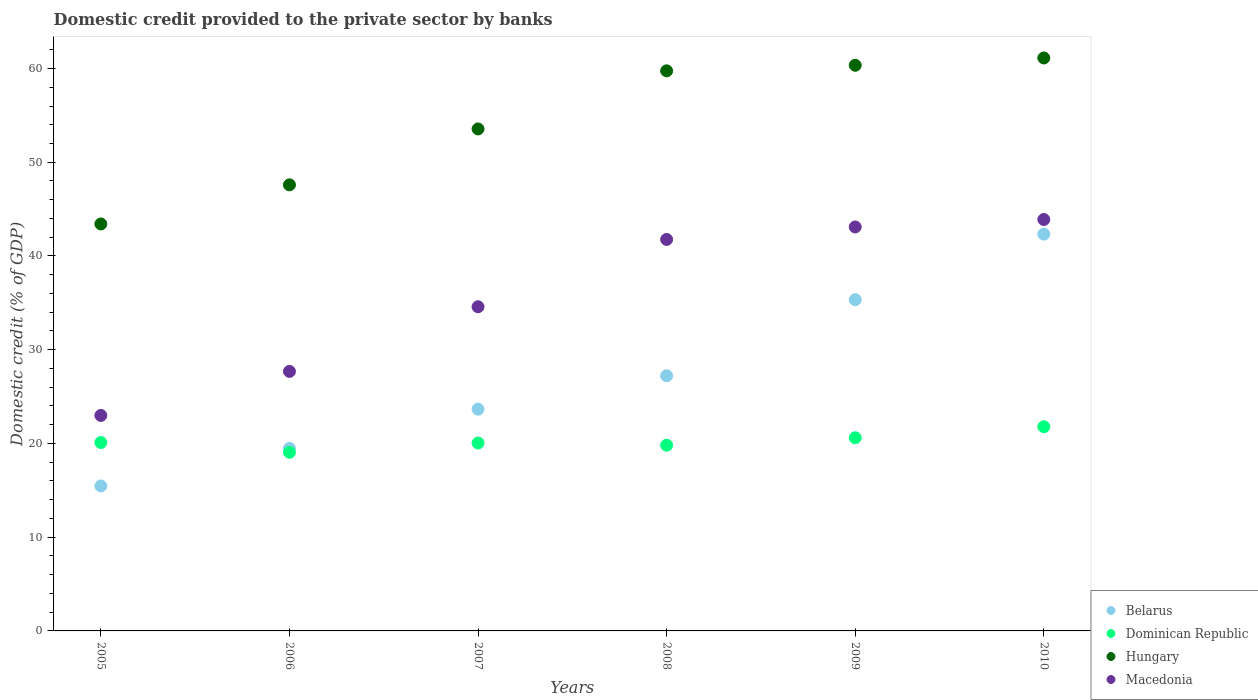How many different coloured dotlines are there?
Make the answer very short. 4. Is the number of dotlines equal to the number of legend labels?
Provide a succinct answer. Yes. What is the domestic credit provided to the private sector by banks in Belarus in 2008?
Ensure brevity in your answer.  27.22. Across all years, what is the maximum domestic credit provided to the private sector by banks in Dominican Republic?
Make the answer very short. 21.79. Across all years, what is the minimum domestic credit provided to the private sector by banks in Dominican Republic?
Provide a succinct answer. 19.05. In which year was the domestic credit provided to the private sector by banks in Hungary minimum?
Provide a short and direct response. 2005. What is the total domestic credit provided to the private sector by banks in Dominican Republic in the graph?
Your response must be concise. 121.41. What is the difference between the domestic credit provided to the private sector by banks in Dominican Republic in 2006 and that in 2010?
Ensure brevity in your answer.  -2.73. What is the difference between the domestic credit provided to the private sector by banks in Macedonia in 2005 and the domestic credit provided to the private sector by banks in Hungary in 2009?
Offer a very short reply. -37.36. What is the average domestic credit provided to the private sector by banks in Belarus per year?
Give a very brief answer. 27.25. In the year 2008, what is the difference between the domestic credit provided to the private sector by banks in Hungary and domestic credit provided to the private sector by banks in Macedonia?
Keep it short and to the point. 17.99. What is the ratio of the domestic credit provided to the private sector by banks in Hungary in 2008 to that in 2010?
Your answer should be very brief. 0.98. Is the domestic credit provided to the private sector by banks in Belarus in 2005 less than that in 2009?
Offer a very short reply. Yes. What is the difference between the highest and the second highest domestic credit provided to the private sector by banks in Dominican Republic?
Give a very brief answer. 1.18. What is the difference between the highest and the lowest domestic credit provided to the private sector by banks in Hungary?
Provide a succinct answer. 17.71. Is it the case that in every year, the sum of the domestic credit provided to the private sector by banks in Macedonia and domestic credit provided to the private sector by banks in Dominican Republic  is greater than the sum of domestic credit provided to the private sector by banks in Belarus and domestic credit provided to the private sector by banks in Hungary?
Ensure brevity in your answer.  No. Is it the case that in every year, the sum of the domestic credit provided to the private sector by banks in Macedonia and domestic credit provided to the private sector by banks in Belarus  is greater than the domestic credit provided to the private sector by banks in Hungary?
Provide a short and direct response. No. Is the domestic credit provided to the private sector by banks in Macedonia strictly less than the domestic credit provided to the private sector by banks in Belarus over the years?
Your response must be concise. No. How many years are there in the graph?
Provide a succinct answer. 6. What is the difference between two consecutive major ticks on the Y-axis?
Your response must be concise. 10. Does the graph contain any zero values?
Provide a succinct answer. No. Does the graph contain grids?
Your answer should be very brief. No. Where does the legend appear in the graph?
Provide a short and direct response. Bottom right. How many legend labels are there?
Offer a terse response. 4. What is the title of the graph?
Ensure brevity in your answer.  Domestic credit provided to the private sector by banks. What is the label or title of the X-axis?
Your answer should be compact. Years. What is the label or title of the Y-axis?
Ensure brevity in your answer.  Domestic credit (% of GDP). What is the Domestic credit (% of GDP) in Belarus in 2005?
Your response must be concise. 15.47. What is the Domestic credit (% of GDP) of Dominican Republic in 2005?
Provide a short and direct response. 20.1. What is the Domestic credit (% of GDP) in Hungary in 2005?
Offer a terse response. 43.42. What is the Domestic credit (% of GDP) of Macedonia in 2005?
Your answer should be very brief. 22.99. What is the Domestic credit (% of GDP) in Belarus in 2006?
Your answer should be compact. 19.48. What is the Domestic credit (% of GDP) in Dominican Republic in 2006?
Ensure brevity in your answer.  19.05. What is the Domestic credit (% of GDP) of Hungary in 2006?
Offer a very short reply. 47.59. What is the Domestic credit (% of GDP) in Macedonia in 2006?
Your response must be concise. 27.69. What is the Domestic credit (% of GDP) of Belarus in 2007?
Provide a short and direct response. 23.66. What is the Domestic credit (% of GDP) in Dominican Republic in 2007?
Keep it short and to the point. 20.05. What is the Domestic credit (% of GDP) in Hungary in 2007?
Make the answer very short. 53.55. What is the Domestic credit (% of GDP) in Macedonia in 2007?
Your answer should be very brief. 34.58. What is the Domestic credit (% of GDP) in Belarus in 2008?
Keep it short and to the point. 27.22. What is the Domestic credit (% of GDP) of Dominican Republic in 2008?
Ensure brevity in your answer.  19.81. What is the Domestic credit (% of GDP) of Hungary in 2008?
Make the answer very short. 59.75. What is the Domestic credit (% of GDP) in Macedonia in 2008?
Your response must be concise. 41.76. What is the Domestic credit (% of GDP) of Belarus in 2009?
Give a very brief answer. 35.34. What is the Domestic credit (% of GDP) in Dominican Republic in 2009?
Ensure brevity in your answer.  20.61. What is the Domestic credit (% of GDP) of Hungary in 2009?
Provide a succinct answer. 60.34. What is the Domestic credit (% of GDP) in Macedonia in 2009?
Offer a very short reply. 43.1. What is the Domestic credit (% of GDP) of Belarus in 2010?
Keep it short and to the point. 42.33. What is the Domestic credit (% of GDP) of Dominican Republic in 2010?
Make the answer very short. 21.79. What is the Domestic credit (% of GDP) of Hungary in 2010?
Make the answer very short. 61.12. What is the Domestic credit (% of GDP) in Macedonia in 2010?
Your answer should be very brief. 43.89. Across all years, what is the maximum Domestic credit (% of GDP) of Belarus?
Provide a short and direct response. 42.33. Across all years, what is the maximum Domestic credit (% of GDP) of Dominican Republic?
Your answer should be compact. 21.79. Across all years, what is the maximum Domestic credit (% of GDP) in Hungary?
Offer a terse response. 61.12. Across all years, what is the maximum Domestic credit (% of GDP) in Macedonia?
Offer a terse response. 43.89. Across all years, what is the minimum Domestic credit (% of GDP) in Belarus?
Provide a short and direct response. 15.47. Across all years, what is the minimum Domestic credit (% of GDP) in Dominican Republic?
Offer a terse response. 19.05. Across all years, what is the minimum Domestic credit (% of GDP) in Hungary?
Your answer should be compact. 43.42. Across all years, what is the minimum Domestic credit (% of GDP) of Macedonia?
Keep it short and to the point. 22.99. What is the total Domestic credit (% of GDP) in Belarus in the graph?
Offer a very short reply. 163.5. What is the total Domestic credit (% of GDP) of Dominican Republic in the graph?
Your response must be concise. 121.41. What is the total Domestic credit (% of GDP) in Hungary in the graph?
Make the answer very short. 325.78. What is the total Domestic credit (% of GDP) of Macedonia in the graph?
Offer a very short reply. 214.01. What is the difference between the Domestic credit (% of GDP) of Belarus in 2005 and that in 2006?
Make the answer very short. -4.01. What is the difference between the Domestic credit (% of GDP) in Dominican Republic in 2005 and that in 2006?
Provide a succinct answer. 1.05. What is the difference between the Domestic credit (% of GDP) of Hungary in 2005 and that in 2006?
Keep it short and to the point. -4.17. What is the difference between the Domestic credit (% of GDP) of Macedonia in 2005 and that in 2006?
Offer a terse response. -4.7. What is the difference between the Domestic credit (% of GDP) in Belarus in 2005 and that in 2007?
Your answer should be compact. -8.19. What is the difference between the Domestic credit (% of GDP) of Dominican Republic in 2005 and that in 2007?
Your response must be concise. 0.05. What is the difference between the Domestic credit (% of GDP) in Hungary in 2005 and that in 2007?
Make the answer very short. -10.14. What is the difference between the Domestic credit (% of GDP) of Macedonia in 2005 and that in 2007?
Your answer should be compact. -11.6. What is the difference between the Domestic credit (% of GDP) of Belarus in 2005 and that in 2008?
Provide a succinct answer. -11.76. What is the difference between the Domestic credit (% of GDP) of Dominican Republic in 2005 and that in 2008?
Offer a terse response. 0.29. What is the difference between the Domestic credit (% of GDP) in Hungary in 2005 and that in 2008?
Offer a terse response. -16.33. What is the difference between the Domestic credit (% of GDP) in Macedonia in 2005 and that in 2008?
Your response must be concise. -18.78. What is the difference between the Domestic credit (% of GDP) of Belarus in 2005 and that in 2009?
Offer a very short reply. -19.87. What is the difference between the Domestic credit (% of GDP) of Dominican Republic in 2005 and that in 2009?
Ensure brevity in your answer.  -0.5. What is the difference between the Domestic credit (% of GDP) in Hungary in 2005 and that in 2009?
Make the answer very short. -16.93. What is the difference between the Domestic credit (% of GDP) of Macedonia in 2005 and that in 2009?
Give a very brief answer. -20.11. What is the difference between the Domestic credit (% of GDP) in Belarus in 2005 and that in 2010?
Offer a terse response. -26.87. What is the difference between the Domestic credit (% of GDP) of Dominican Republic in 2005 and that in 2010?
Your answer should be compact. -1.68. What is the difference between the Domestic credit (% of GDP) of Hungary in 2005 and that in 2010?
Ensure brevity in your answer.  -17.71. What is the difference between the Domestic credit (% of GDP) in Macedonia in 2005 and that in 2010?
Make the answer very short. -20.9. What is the difference between the Domestic credit (% of GDP) of Belarus in 2006 and that in 2007?
Offer a very short reply. -4.18. What is the difference between the Domestic credit (% of GDP) of Dominican Republic in 2006 and that in 2007?
Provide a succinct answer. -1. What is the difference between the Domestic credit (% of GDP) in Hungary in 2006 and that in 2007?
Make the answer very short. -5.96. What is the difference between the Domestic credit (% of GDP) in Macedonia in 2006 and that in 2007?
Offer a terse response. -6.89. What is the difference between the Domestic credit (% of GDP) in Belarus in 2006 and that in 2008?
Offer a terse response. -7.75. What is the difference between the Domestic credit (% of GDP) in Dominican Republic in 2006 and that in 2008?
Your response must be concise. -0.76. What is the difference between the Domestic credit (% of GDP) in Hungary in 2006 and that in 2008?
Offer a terse response. -12.16. What is the difference between the Domestic credit (% of GDP) of Macedonia in 2006 and that in 2008?
Ensure brevity in your answer.  -14.08. What is the difference between the Domestic credit (% of GDP) of Belarus in 2006 and that in 2009?
Offer a terse response. -15.86. What is the difference between the Domestic credit (% of GDP) of Dominican Republic in 2006 and that in 2009?
Make the answer very short. -1.55. What is the difference between the Domestic credit (% of GDP) in Hungary in 2006 and that in 2009?
Keep it short and to the point. -12.75. What is the difference between the Domestic credit (% of GDP) of Macedonia in 2006 and that in 2009?
Provide a succinct answer. -15.41. What is the difference between the Domestic credit (% of GDP) of Belarus in 2006 and that in 2010?
Your answer should be very brief. -22.86. What is the difference between the Domestic credit (% of GDP) in Dominican Republic in 2006 and that in 2010?
Keep it short and to the point. -2.73. What is the difference between the Domestic credit (% of GDP) in Hungary in 2006 and that in 2010?
Provide a short and direct response. -13.53. What is the difference between the Domestic credit (% of GDP) in Macedonia in 2006 and that in 2010?
Your response must be concise. -16.2. What is the difference between the Domestic credit (% of GDP) of Belarus in 2007 and that in 2008?
Your answer should be very brief. -3.56. What is the difference between the Domestic credit (% of GDP) in Dominican Republic in 2007 and that in 2008?
Your answer should be compact. 0.23. What is the difference between the Domestic credit (% of GDP) of Hungary in 2007 and that in 2008?
Offer a terse response. -6.2. What is the difference between the Domestic credit (% of GDP) of Macedonia in 2007 and that in 2008?
Make the answer very short. -7.18. What is the difference between the Domestic credit (% of GDP) of Belarus in 2007 and that in 2009?
Keep it short and to the point. -11.68. What is the difference between the Domestic credit (% of GDP) in Dominican Republic in 2007 and that in 2009?
Make the answer very short. -0.56. What is the difference between the Domestic credit (% of GDP) in Hungary in 2007 and that in 2009?
Give a very brief answer. -6.79. What is the difference between the Domestic credit (% of GDP) of Macedonia in 2007 and that in 2009?
Keep it short and to the point. -8.51. What is the difference between the Domestic credit (% of GDP) in Belarus in 2007 and that in 2010?
Provide a short and direct response. -18.67. What is the difference between the Domestic credit (% of GDP) in Dominican Republic in 2007 and that in 2010?
Keep it short and to the point. -1.74. What is the difference between the Domestic credit (% of GDP) of Hungary in 2007 and that in 2010?
Give a very brief answer. -7.57. What is the difference between the Domestic credit (% of GDP) of Macedonia in 2007 and that in 2010?
Ensure brevity in your answer.  -9.31. What is the difference between the Domestic credit (% of GDP) of Belarus in 2008 and that in 2009?
Your response must be concise. -8.12. What is the difference between the Domestic credit (% of GDP) in Dominican Republic in 2008 and that in 2009?
Give a very brief answer. -0.79. What is the difference between the Domestic credit (% of GDP) of Hungary in 2008 and that in 2009?
Offer a very short reply. -0.59. What is the difference between the Domestic credit (% of GDP) of Macedonia in 2008 and that in 2009?
Your response must be concise. -1.33. What is the difference between the Domestic credit (% of GDP) in Belarus in 2008 and that in 2010?
Provide a short and direct response. -15.11. What is the difference between the Domestic credit (% of GDP) of Dominican Republic in 2008 and that in 2010?
Offer a terse response. -1.97. What is the difference between the Domestic credit (% of GDP) in Hungary in 2008 and that in 2010?
Offer a very short reply. -1.37. What is the difference between the Domestic credit (% of GDP) in Macedonia in 2008 and that in 2010?
Give a very brief answer. -2.13. What is the difference between the Domestic credit (% of GDP) of Belarus in 2009 and that in 2010?
Offer a very short reply. -6.99. What is the difference between the Domestic credit (% of GDP) of Dominican Republic in 2009 and that in 2010?
Offer a terse response. -1.18. What is the difference between the Domestic credit (% of GDP) of Hungary in 2009 and that in 2010?
Ensure brevity in your answer.  -0.78. What is the difference between the Domestic credit (% of GDP) of Macedonia in 2009 and that in 2010?
Your response must be concise. -0.8. What is the difference between the Domestic credit (% of GDP) in Belarus in 2005 and the Domestic credit (% of GDP) in Dominican Republic in 2006?
Give a very brief answer. -3.59. What is the difference between the Domestic credit (% of GDP) of Belarus in 2005 and the Domestic credit (% of GDP) of Hungary in 2006?
Make the answer very short. -32.12. What is the difference between the Domestic credit (% of GDP) of Belarus in 2005 and the Domestic credit (% of GDP) of Macedonia in 2006?
Offer a very short reply. -12.22. What is the difference between the Domestic credit (% of GDP) in Dominican Republic in 2005 and the Domestic credit (% of GDP) in Hungary in 2006?
Offer a terse response. -27.49. What is the difference between the Domestic credit (% of GDP) of Dominican Republic in 2005 and the Domestic credit (% of GDP) of Macedonia in 2006?
Your answer should be compact. -7.59. What is the difference between the Domestic credit (% of GDP) in Hungary in 2005 and the Domestic credit (% of GDP) in Macedonia in 2006?
Your response must be concise. 15.73. What is the difference between the Domestic credit (% of GDP) of Belarus in 2005 and the Domestic credit (% of GDP) of Dominican Republic in 2007?
Offer a terse response. -4.58. What is the difference between the Domestic credit (% of GDP) in Belarus in 2005 and the Domestic credit (% of GDP) in Hungary in 2007?
Your response must be concise. -38.09. What is the difference between the Domestic credit (% of GDP) of Belarus in 2005 and the Domestic credit (% of GDP) of Macedonia in 2007?
Your response must be concise. -19.12. What is the difference between the Domestic credit (% of GDP) in Dominican Republic in 2005 and the Domestic credit (% of GDP) in Hungary in 2007?
Your answer should be very brief. -33.45. What is the difference between the Domestic credit (% of GDP) of Dominican Republic in 2005 and the Domestic credit (% of GDP) of Macedonia in 2007?
Provide a short and direct response. -14.48. What is the difference between the Domestic credit (% of GDP) in Hungary in 2005 and the Domestic credit (% of GDP) in Macedonia in 2007?
Your answer should be compact. 8.83. What is the difference between the Domestic credit (% of GDP) of Belarus in 2005 and the Domestic credit (% of GDP) of Dominican Republic in 2008?
Your response must be concise. -4.35. What is the difference between the Domestic credit (% of GDP) in Belarus in 2005 and the Domestic credit (% of GDP) in Hungary in 2008?
Offer a terse response. -44.28. What is the difference between the Domestic credit (% of GDP) in Belarus in 2005 and the Domestic credit (% of GDP) in Macedonia in 2008?
Offer a very short reply. -26.3. What is the difference between the Domestic credit (% of GDP) of Dominican Republic in 2005 and the Domestic credit (% of GDP) of Hungary in 2008?
Offer a terse response. -39.65. What is the difference between the Domestic credit (% of GDP) in Dominican Republic in 2005 and the Domestic credit (% of GDP) in Macedonia in 2008?
Your answer should be compact. -21.66. What is the difference between the Domestic credit (% of GDP) of Hungary in 2005 and the Domestic credit (% of GDP) of Macedonia in 2008?
Make the answer very short. 1.65. What is the difference between the Domestic credit (% of GDP) of Belarus in 2005 and the Domestic credit (% of GDP) of Dominican Republic in 2009?
Your answer should be compact. -5.14. What is the difference between the Domestic credit (% of GDP) of Belarus in 2005 and the Domestic credit (% of GDP) of Hungary in 2009?
Your response must be concise. -44.88. What is the difference between the Domestic credit (% of GDP) of Belarus in 2005 and the Domestic credit (% of GDP) of Macedonia in 2009?
Offer a terse response. -27.63. What is the difference between the Domestic credit (% of GDP) in Dominican Republic in 2005 and the Domestic credit (% of GDP) in Hungary in 2009?
Ensure brevity in your answer.  -40.24. What is the difference between the Domestic credit (% of GDP) of Dominican Republic in 2005 and the Domestic credit (% of GDP) of Macedonia in 2009?
Ensure brevity in your answer.  -22.99. What is the difference between the Domestic credit (% of GDP) in Hungary in 2005 and the Domestic credit (% of GDP) in Macedonia in 2009?
Ensure brevity in your answer.  0.32. What is the difference between the Domestic credit (% of GDP) in Belarus in 2005 and the Domestic credit (% of GDP) in Dominican Republic in 2010?
Make the answer very short. -6.32. What is the difference between the Domestic credit (% of GDP) in Belarus in 2005 and the Domestic credit (% of GDP) in Hungary in 2010?
Your answer should be very brief. -45.66. What is the difference between the Domestic credit (% of GDP) of Belarus in 2005 and the Domestic credit (% of GDP) of Macedonia in 2010?
Ensure brevity in your answer.  -28.43. What is the difference between the Domestic credit (% of GDP) of Dominican Republic in 2005 and the Domestic credit (% of GDP) of Hungary in 2010?
Offer a very short reply. -41.02. What is the difference between the Domestic credit (% of GDP) of Dominican Republic in 2005 and the Domestic credit (% of GDP) of Macedonia in 2010?
Offer a very short reply. -23.79. What is the difference between the Domestic credit (% of GDP) of Hungary in 2005 and the Domestic credit (% of GDP) of Macedonia in 2010?
Offer a very short reply. -0.48. What is the difference between the Domestic credit (% of GDP) in Belarus in 2006 and the Domestic credit (% of GDP) in Dominican Republic in 2007?
Offer a very short reply. -0.57. What is the difference between the Domestic credit (% of GDP) of Belarus in 2006 and the Domestic credit (% of GDP) of Hungary in 2007?
Make the answer very short. -34.08. What is the difference between the Domestic credit (% of GDP) of Belarus in 2006 and the Domestic credit (% of GDP) of Macedonia in 2007?
Your answer should be compact. -15.11. What is the difference between the Domestic credit (% of GDP) of Dominican Republic in 2006 and the Domestic credit (% of GDP) of Hungary in 2007?
Offer a terse response. -34.5. What is the difference between the Domestic credit (% of GDP) of Dominican Republic in 2006 and the Domestic credit (% of GDP) of Macedonia in 2007?
Ensure brevity in your answer.  -15.53. What is the difference between the Domestic credit (% of GDP) of Hungary in 2006 and the Domestic credit (% of GDP) of Macedonia in 2007?
Give a very brief answer. 13.01. What is the difference between the Domestic credit (% of GDP) in Belarus in 2006 and the Domestic credit (% of GDP) in Dominican Republic in 2008?
Your answer should be compact. -0.34. What is the difference between the Domestic credit (% of GDP) of Belarus in 2006 and the Domestic credit (% of GDP) of Hungary in 2008?
Provide a succinct answer. -40.28. What is the difference between the Domestic credit (% of GDP) of Belarus in 2006 and the Domestic credit (% of GDP) of Macedonia in 2008?
Provide a succinct answer. -22.29. What is the difference between the Domestic credit (% of GDP) in Dominican Republic in 2006 and the Domestic credit (% of GDP) in Hungary in 2008?
Ensure brevity in your answer.  -40.7. What is the difference between the Domestic credit (% of GDP) in Dominican Republic in 2006 and the Domestic credit (% of GDP) in Macedonia in 2008?
Offer a very short reply. -22.71. What is the difference between the Domestic credit (% of GDP) of Hungary in 2006 and the Domestic credit (% of GDP) of Macedonia in 2008?
Your answer should be compact. 5.83. What is the difference between the Domestic credit (% of GDP) of Belarus in 2006 and the Domestic credit (% of GDP) of Dominican Republic in 2009?
Offer a terse response. -1.13. What is the difference between the Domestic credit (% of GDP) in Belarus in 2006 and the Domestic credit (% of GDP) in Hungary in 2009?
Give a very brief answer. -40.87. What is the difference between the Domestic credit (% of GDP) in Belarus in 2006 and the Domestic credit (% of GDP) in Macedonia in 2009?
Make the answer very short. -23.62. What is the difference between the Domestic credit (% of GDP) of Dominican Republic in 2006 and the Domestic credit (% of GDP) of Hungary in 2009?
Keep it short and to the point. -41.29. What is the difference between the Domestic credit (% of GDP) of Dominican Republic in 2006 and the Domestic credit (% of GDP) of Macedonia in 2009?
Give a very brief answer. -24.04. What is the difference between the Domestic credit (% of GDP) of Hungary in 2006 and the Domestic credit (% of GDP) of Macedonia in 2009?
Offer a very short reply. 4.49. What is the difference between the Domestic credit (% of GDP) of Belarus in 2006 and the Domestic credit (% of GDP) of Dominican Republic in 2010?
Make the answer very short. -2.31. What is the difference between the Domestic credit (% of GDP) in Belarus in 2006 and the Domestic credit (% of GDP) in Hungary in 2010?
Make the answer very short. -41.65. What is the difference between the Domestic credit (% of GDP) of Belarus in 2006 and the Domestic credit (% of GDP) of Macedonia in 2010?
Ensure brevity in your answer.  -24.42. What is the difference between the Domestic credit (% of GDP) of Dominican Republic in 2006 and the Domestic credit (% of GDP) of Hungary in 2010?
Provide a succinct answer. -42.07. What is the difference between the Domestic credit (% of GDP) of Dominican Republic in 2006 and the Domestic credit (% of GDP) of Macedonia in 2010?
Keep it short and to the point. -24.84. What is the difference between the Domestic credit (% of GDP) in Hungary in 2006 and the Domestic credit (% of GDP) in Macedonia in 2010?
Your answer should be very brief. 3.7. What is the difference between the Domestic credit (% of GDP) in Belarus in 2007 and the Domestic credit (% of GDP) in Dominican Republic in 2008?
Your answer should be compact. 3.84. What is the difference between the Domestic credit (% of GDP) in Belarus in 2007 and the Domestic credit (% of GDP) in Hungary in 2008?
Provide a short and direct response. -36.09. What is the difference between the Domestic credit (% of GDP) of Belarus in 2007 and the Domestic credit (% of GDP) of Macedonia in 2008?
Offer a terse response. -18.1. What is the difference between the Domestic credit (% of GDP) of Dominican Republic in 2007 and the Domestic credit (% of GDP) of Hungary in 2008?
Offer a very short reply. -39.7. What is the difference between the Domestic credit (% of GDP) in Dominican Republic in 2007 and the Domestic credit (% of GDP) in Macedonia in 2008?
Make the answer very short. -21.72. What is the difference between the Domestic credit (% of GDP) of Hungary in 2007 and the Domestic credit (% of GDP) of Macedonia in 2008?
Offer a terse response. 11.79. What is the difference between the Domestic credit (% of GDP) in Belarus in 2007 and the Domestic credit (% of GDP) in Dominican Republic in 2009?
Offer a terse response. 3.05. What is the difference between the Domestic credit (% of GDP) in Belarus in 2007 and the Domestic credit (% of GDP) in Hungary in 2009?
Your answer should be compact. -36.68. What is the difference between the Domestic credit (% of GDP) of Belarus in 2007 and the Domestic credit (% of GDP) of Macedonia in 2009?
Offer a terse response. -19.44. What is the difference between the Domestic credit (% of GDP) in Dominican Republic in 2007 and the Domestic credit (% of GDP) in Hungary in 2009?
Offer a very short reply. -40.3. What is the difference between the Domestic credit (% of GDP) of Dominican Republic in 2007 and the Domestic credit (% of GDP) of Macedonia in 2009?
Your answer should be very brief. -23.05. What is the difference between the Domestic credit (% of GDP) in Hungary in 2007 and the Domestic credit (% of GDP) in Macedonia in 2009?
Provide a short and direct response. 10.46. What is the difference between the Domestic credit (% of GDP) in Belarus in 2007 and the Domestic credit (% of GDP) in Dominican Republic in 2010?
Offer a terse response. 1.87. What is the difference between the Domestic credit (% of GDP) in Belarus in 2007 and the Domestic credit (% of GDP) in Hungary in 2010?
Offer a very short reply. -37.46. What is the difference between the Domestic credit (% of GDP) of Belarus in 2007 and the Domestic credit (% of GDP) of Macedonia in 2010?
Make the answer very short. -20.23. What is the difference between the Domestic credit (% of GDP) of Dominican Republic in 2007 and the Domestic credit (% of GDP) of Hungary in 2010?
Offer a very short reply. -41.08. What is the difference between the Domestic credit (% of GDP) of Dominican Republic in 2007 and the Domestic credit (% of GDP) of Macedonia in 2010?
Your response must be concise. -23.84. What is the difference between the Domestic credit (% of GDP) in Hungary in 2007 and the Domestic credit (% of GDP) in Macedonia in 2010?
Your answer should be very brief. 9.66. What is the difference between the Domestic credit (% of GDP) of Belarus in 2008 and the Domestic credit (% of GDP) of Dominican Republic in 2009?
Your response must be concise. 6.61. What is the difference between the Domestic credit (% of GDP) in Belarus in 2008 and the Domestic credit (% of GDP) in Hungary in 2009?
Offer a very short reply. -33.12. What is the difference between the Domestic credit (% of GDP) in Belarus in 2008 and the Domestic credit (% of GDP) in Macedonia in 2009?
Your answer should be compact. -15.87. What is the difference between the Domestic credit (% of GDP) of Dominican Republic in 2008 and the Domestic credit (% of GDP) of Hungary in 2009?
Give a very brief answer. -40.53. What is the difference between the Domestic credit (% of GDP) of Dominican Republic in 2008 and the Domestic credit (% of GDP) of Macedonia in 2009?
Make the answer very short. -23.28. What is the difference between the Domestic credit (% of GDP) of Hungary in 2008 and the Domestic credit (% of GDP) of Macedonia in 2009?
Provide a short and direct response. 16.66. What is the difference between the Domestic credit (% of GDP) in Belarus in 2008 and the Domestic credit (% of GDP) in Dominican Republic in 2010?
Offer a very short reply. 5.44. What is the difference between the Domestic credit (% of GDP) of Belarus in 2008 and the Domestic credit (% of GDP) of Hungary in 2010?
Your answer should be compact. -33.9. What is the difference between the Domestic credit (% of GDP) of Belarus in 2008 and the Domestic credit (% of GDP) of Macedonia in 2010?
Provide a succinct answer. -16.67. What is the difference between the Domestic credit (% of GDP) of Dominican Republic in 2008 and the Domestic credit (% of GDP) of Hungary in 2010?
Your response must be concise. -41.31. What is the difference between the Domestic credit (% of GDP) in Dominican Republic in 2008 and the Domestic credit (% of GDP) in Macedonia in 2010?
Your answer should be compact. -24.08. What is the difference between the Domestic credit (% of GDP) of Hungary in 2008 and the Domestic credit (% of GDP) of Macedonia in 2010?
Provide a succinct answer. 15.86. What is the difference between the Domestic credit (% of GDP) of Belarus in 2009 and the Domestic credit (% of GDP) of Dominican Republic in 2010?
Give a very brief answer. 13.55. What is the difference between the Domestic credit (% of GDP) in Belarus in 2009 and the Domestic credit (% of GDP) in Hungary in 2010?
Offer a very short reply. -25.78. What is the difference between the Domestic credit (% of GDP) of Belarus in 2009 and the Domestic credit (% of GDP) of Macedonia in 2010?
Offer a terse response. -8.55. What is the difference between the Domestic credit (% of GDP) of Dominican Republic in 2009 and the Domestic credit (% of GDP) of Hungary in 2010?
Your response must be concise. -40.52. What is the difference between the Domestic credit (% of GDP) of Dominican Republic in 2009 and the Domestic credit (% of GDP) of Macedonia in 2010?
Keep it short and to the point. -23.29. What is the difference between the Domestic credit (% of GDP) in Hungary in 2009 and the Domestic credit (% of GDP) in Macedonia in 2010?
Make the answer very short. 16.45. What is the average Domestic credit (% of GDP) in Belarus per year?
Offer a very short reply. 27.25. What is the average Domestic credit (% of GDP) of Dominican Republic per year?
Provide a succinct answer. 20.23. What is the average Domestic credit (% of GDP) of Hungary per year?
Make the answer very short. 54.3. What is the average Domestic credit (% of GDP) in Macedonia per year?
Give a very brief answer. 35.67. In the year 2005, what is the difference between the Domestic credit (% of GDP) of Belarus and Domestic credit (% of GDP) of Dominican Republic?
Ensure brevity in your answer.  -4.64. In the year 2005, what is the difference between the Domestic credit (% of GDP) in Belarus and Domestic credit (% of GDP) in Hungary?
Make the answer very short. -27.95. In the year 2005, what is the difference between the Domestic credit (% of GDP) of Belarus and Domestic credit (% of GDP) of Macedonia?
Offer a very short reply. -7.52. In the year 2005, what is the difference between the Domestic credit (% of GDP) of Dominican Republic and Domestic credit (% of GDP) of Hungary?
Offer a terse response. -23.31. In the year 2005, what is the difference between the Domestic credit (% of GDP) in Dominican Republic and Domestic credit (% of GDP) in Macedonia?
Your response must be concise. -2.89. In the year 2005, what is the difference between the Domestic credit (% of GDP) of Hungary and Domestic credit (% of GDP) of Macedonia?
Provide a short and direct response. 20.43. In the year 2006, what is the difference between the Domestic credit (% of GDP) of Belarus and Domestic credit (% of GDP) of Dominican Republic?
Keep it short and to the point. 0.42. In the year 2006, what is the difference between the Domestic credit (% of GDP) of Belarus and Domestic credit (% of GDP) of Hungary?
Offer a very short reply. -28.11. In the year 2006, what is the difference between the Domestic credit (% of GDP) of Belarus and Domestic credit (% of GDP) of Macedonia?
Provide a succinct answer. -8.21. In the year 2006, what is the difference between the Domestic credit (% of GDP) of Dominican Republic and Domestic credit (% of GDP) of Hungary?
Your answer should be very brief. -28.54. In the year 2006, what is the difference between the Domestic credit (% of GDP) of Dominican Republic and Domestic credit (% of GDP) of Macedonia?
Give a very brief answer. -8.64. In the year 2006, what is the difference between the Domestic credit (% of GDP) of Hungary and Domestic credit (% of GDP) of Macedonia?
Provide a short and direct response. 19.9. In the year 2007, what is the difference between the Domestic credit (% of GDP) in Belarus and Domestic credit (% of GDP) in Dominican Republic?
Your answer should be very brief. 3.61. In the year 2007, what is the difference between the Domestic credit (% of GDP) of Belarus and Domestic credit (% of GDP) of Hungary?
Provide a succinct answer. -29.89. In the year 2007, what is the difference between the Domestic credit (% of GDP) of Belarus and Domestic credit (% of GDP) of Macedonia?
Keep it short and to the point. -10.92. In the year 2007, what is the difference between the Domestic credit (% of GDP) of Dominican Republic and Domestic credit (% of GDP) of Hungary?
Offer a terse response. -33.5. In the year 2007, what is the difference between the Domestic credit (% of GDP) of Dominican Republic and Domestic credit (% of GDP) of Macedonia?
Offer a terse response. -14.53. In the year 2007, what is the difference between the Domestic credit (% of GDP) of Hungary and Domestic credit (% of GDP) of Macedonia?
Keep it short and to the point. 18.97. In the year 2008, what is the difference between the Domestic credit (% of GDP) in Belarus and Domestic credit (% of GDP) in Dominican Republic?
Offer a terse response. 7.41. In the year 2008, what is the difference between the Domestic credit (% of GDP) of Belarus and Domestic credit (% of GDP) of Hungary?
Give a very brief answer. -32.53. In the year 2008, what is the difference between the Domestic credit (% of GDP) of Belarus and Domestic credit (% of GDP) of Macedonia?
Provide a short and direct response. -14.54. In the year 2008, what is the difference between the Domestic credit (% of GDP) of Dominican Republic and Domestic credit (% of GDP) of Hungary?
Give a very brief answer. -39.94. In the year 2008, what is the difference between the Domestic credit (% of GDP) of Dominican Republic and Domestic credit (% of GDP) of Macedonia?
Your answer should be compact. -21.95. In the year 2008, what is the difference between the Domestic credit (% of GDP) of Hungary and Domestic credit (% of GDP) of Macedonia?
Make the answer very short. 17.99. In the year 2009, what is the difference between the Domestic credit (% of GDP) in Belarus and Domestic credit (% of GDP) in Dominican Republic?
Offer a very short reply. 14.73. In the year 2009, what is the difference between the Domestic credit (% of GDP) of Belarus and Domestic credit (% of GDP) of Hungary?
Give a very brief answer. -25. In the year 2009, what is the difference between the Domestic credit (% of GDP) of Belarus and Domestic credit (% of GDP) of Macedonia?
Your response must be concise. -7.76. In the year 2009, what is the difference between the Domestic credit (% of GDP) of Dominican Republic and Domestic credit (% of GDP) of Hungary?
Provide a succinct answer. -39.74. In the year 2009, what is the difference between the Domestic credit (% of GDP) of Dominican Republic and Domestic credit (% of GDP) of Macedonia?
Provide a succinct answer. -22.49. In the year 2009, what is the difference between the Domestic credit (% of GDP) in Hungary and Domestic credit (% of GDP) in Macedonia?
Provide a succinct answer. 17.25. In the year 2010, what is the difference between the Domestic credit (% of GDP) in Belarus and Domestic credit (% of GDP) in Dominican Republic?
Keep it short and to the point. 20.55. In the year 2010, what is the difference between the Domestic credit (% of GDP) in Belarus and Domestic credit (% of GDP) in Hungary?
Your answer should be compact. -18.79. In the year 2010, what is the difference between the Domestic credit (% of GDP) of Belarus and Domestic credit (% of GDP) of Macedonia?
Your answer should be very brief. -1.56. In the year 2010, what is the difference between the Domestic credit (% of GDP) in Dominican Republic and Domestic credit (% of GDP) in Hungary?
Provide a short and direct response. -39.34. In the year 2010, what is the difference between the Domestic credit (% of GDP) in Dominican Republic and Domestic credit (% of GDP) in Macedonia?
Provide a short and direct response. -22.11. In the year 2010, what is the difference between the Domestic credit (% of GDP) of Hungary and Domestic credit (% of GDP) of Macedonia?
Offer a very short reply. 17.23. What is the ratio of the Domestic credit (% of GDP) in Belarus in 2005 to that in 2006?
Offer a very short reply. 0.79. What is the ratio of the Domestic credit (% of GDP) in Dominican Republic in 2005 to that in 2006?
Give a very brief answer. 1.06. What is the ratio of the Domestic credit (% of GDP) of Hungary in 2005 to that in 2006?
Ensure brevity in your answer.  0.91. What is the ratio of the Domestic credit (% of GDP) in Macedonia in 2005 to that in 2006?
Give a very brief answer. 0.83. What is the ratio of the Domestic credit (% of GDP) in Belarus in 2005 to that in 2007?
Your response must be concise. 0.65. What is the ratio of the Domestic credit (% of GDP) in Dominican Republic in 2005 to that in 2007?
Your answer should be very brief. 1. What is the ratio of the Domestic credit (% of GDP) of Hungary in 2005 to that in 2007?
Your answer should be compact. 0.81. What is the ratio of the Domestic credit (% of GDP) in Macedonia in 2005 to that in 2007?
Give a very brief answer. 0.66. What is the ratio of the Domestic credit (% of GDP) of Belarus in 2005 to that in 2008?
Offer a very short reply. 0.57. What is the ratio of the Domestic credit (% of GDP) of Dominican Republic in 2005 to that in 2008?
Ensure brevity in your answer.  1.01. What is the ratio of the Domestic credit (% of GDP) of Hungary in 2005 to that in 2008?
Your answer should be very brief. 0.73. What is the ratio of the Domestic credit (% of GDP) of Macedonia in 2005 to that in 2008?
Give a very brief answer. 0.55. What is the ratio of the Domestic credit (% of GDP) of Belarus in 2005 to that in 2009?
Make the answer very short. 0.44. What is the ratio of the Domestic credit (% of GDP) of Dominican Republic in 2005 to that in 2009?
Keep it short and to the point. 0.98. What is the ratio of the Domestic credit (% of GDP) of Hungary in 2005 to that in 2009?
Provide a succinct answer. 0.72. What is the ratio of the Domestic credit (% of GDP) of Macedonia in 2005 to that in 2009?
Provide a succinct answer. 0.53. What is the ratio of the Domestic credit (% of GDP) of Belarus in 2005 to that in 2010?
Offer a terse response. 0.37. What is the ratio of the Domestic credit (% of GDP) of Dominican Republic in 2005 to that in 2010?
Provide a short and direct response. 0.92. What is the ratio of the Domestic credit (% of GDP) of Hungary in 2005 to that in 2010?
Ensure brevity in your answer.  0.71. What is the ratio of the Domestic credit (% of GDP) of Macedonia in 2005 to that in 2010?
Offer a very short reply. 0.52. What is the ratio of the Domestic credit (% of GDP) in Belarus in 2006 to that in 2007?
Provide a succinct answer. 0.82. What is the ratio of the Domestic credit (% of GDP) in Dominican Republic in 2006 to that in 2007?
Your answer should be compact. 0.95. What is the ratio of the Domestic credit (% of GDP) of Hungary in 2006 to that in 2007?
Keep it short and to the point. 0.89. What is the ratio of the Domestic credit (% of GDP) of Macedonia in 2006 to that in 2007?
Ensure brevity in your answer.  0.8. What is the ratio of the Domestic credit (% of GDP) of Belarus in 2006 to that in 2008?
Ensure brevity in your answer.  0.72. What is the ratio of the Domestic credit (% of GDP) in Dominican Republic in 2006 to that in 2008?
Keep it short and to the point. 0.96. What is the ratio of the Domestic credit (% of GDP) of Hungary in 2006 to that in 2008?
Ensure brevity in your answer.  0.8. What is the ratio of the Domestic credit (% of GDP) in Macedonia in 2006 to that in 2008?
Your response must be concise. 0.66. What is the ratio of the Domestic credit (% of GDP) of Belarus in 2006 to that in 2009?
Ensure brevity in your answer.  0.55. What is the ratio of the Domestic credit (% of GDP) of Dominican Republic in 2006 to that in 2009?
Your response must be concise. 0.92. What is the ratio of the Domestic credit (% of GDP) of Hungary in 2006 to that in 2009?
Your response must be concise. 0.79. What is the ratio of the Domestic credit (% of GDP) in Macedonia in 2006 to that in 2009?
Provide a succinct answer. 0.64. What is the ratio of the Domestic credit (% of GDP) in Belarus in 2006 to that in 2010?
Ensure brevity in your answer.  0.46. What is the ratio of the Domestic credit (% of GDP) in Dominican Republic in 2006 to that in 2010?
Your answer should be compact. 0.87. What is the ratio of the Domestic credit (% of GDP) in Hungary in 2006 to that in 2010?
Ensure brevity in your answer.  0.78. What is the ratio of the Domestic credit (% of GDP) of Macedonia in 2006 to that in 2010?
Your response must be concise. 0.63. What is the ratio of the Domestic credit (% of GDP) in Belarus in 2007 to that in 2008?
Ensure brevity in your answer.  0.87. What is the ratio of the Domestic credit (% of GDP) in Dominican Republic in 2007 to that in 2008?
Ensure brevity in your answer.  1.01. What is the ratio of the Domestic credit (% of GDP) of Hungary in 2007 to that in 2008?
Provide a short and direct response. 0.9. What is the ratio of the Domestic credit (% of GDP) in Macedonia in 2007 to that in 2008?
Offer a terse response. 0.83. What is the ratio of the Domestic credit (% of GDP) in Belarus in 2007 to that in 2009?
Ensure brevity in your answer.  0.67. What is the ratio of the Domestic credit (% of GDP) in Dominican Republic in 2007 to that in 2009?
Offer a very short reply. 0.97. What is the ratio of the Domestic credit (% of GDP) of Hungary in 2007 to that in 2009?
Keep it short and to the point. 0.89. What is the ratio of the Domestic credit (% of GDP) of Macedonia in 2007 to that in 2009?
Your response must be concise. 0.8. What is the ratio of the Domestic credit (% of GDP) of Belarus in 2007 to that in 2010?
Keep it short and to the point. 0.56. What is the ratio of the Domestic credit (% of GDP) in Dominican Republic in 2007 to that in 2010?
Keep it short and to the point. 0.92. What is the ratio of the Domestic credit (% of GDP) in Hungary in 2007 to that in 2010?
Ensure brevity in your answer.  0.88. What is the ratio of the Domestic credit (% of GDP) in Macedonia in 2007 to that in 2010?
Offer a very short reply. 0.79. What is the ratio of the Domestic credit (% of GDP) in Belarus in 2008 to that in 2009?
Ensure brevity in your answer.  0.77. What is the ratio of the Domestic credit (% of GDP) in Dominican Republic in 2008 to that in 2009?
Your answer should be very brief. 0.96. What is the ratio of the Domestic credit (% of GDP) of Hungary in 2008 to that in 2009?
Your answer should be compact. 0.99. What is the ratio of the Domestic credit (% of GDP) in Macedonia in 2008 to that in 2009?
Make the answer very short. 0.97. What is the ratio of the Domestic credit (% of GDP) in Belarus in 2008 to that in 2010?
Offer a terse response. 0.64. What is the ratio of the Domestic credit (% of GDP) in Dominican Republic in 2008 to that in 2010?
Provide a short and direct response. 0.91. What is the ratio of the Domestic credit (% of GDP) in Hungary in 2008 to that in 2010?
Your response must be concise. 0.98. What is the ratio of the Domestic credit (% of GDP) in Macedonia in 2008 to that in 2010?
Offer a terse response. 0.95. What is the ratio of the Domestic credit (% of GDP) in Belarus in 2009 to that in 2010?
Offer a very short reply. 0.83. What is the ratio of the Domestic credit (% of GDP) of Dominican Republic in 2009 to that in 2010?
Ensure brevity in your answer.  0.95. What is the ratio of the Domestic credit (% of GDP) of Hungary in 2009 to that in 2010?
Give a very brief answer. 0.99. What is the ratio of the Domestic credit (% of GDP) in Macedonia in 2009 to that in 2010?
Make the answer very short. 0.98. What is the difference between the highest and the second highest Domestic credit (% of GDP) of Belarus?
Give a very brief answer. 6.99. What is the difference between the highest and the second highest Domestic credit (% of GDP) in Dominican Republic?
Your response must be concise. 1.18. What is the difference between the highest and the second highest Domestic credit (% of GDP) in Hungary?
Your answer should be very brief. 0.78. What is the difference between the highest and the second highest Domestic credit (% of GDP) of Macedonia?
Your response must be concise. 0.8. What is the difference between the highest and the lowest Domestic credit (% of GDP) of Belarus?
Provide a succinct answer. 26.87. What is the difference between the highest and the lowest Domestic credit (% of GDP) of Dominican Republic?
Provide a succinct answer. 2.73. What is the difference between the highest and the lowest Domestic credit (% of GDP) of Hungary?
Ensure brevity in your answer.  17.71. What is the difference between the highest and the lowest Domestic credit (% of GDP) in Macedonia?
Ensure brevity in your answer.  20.9. 